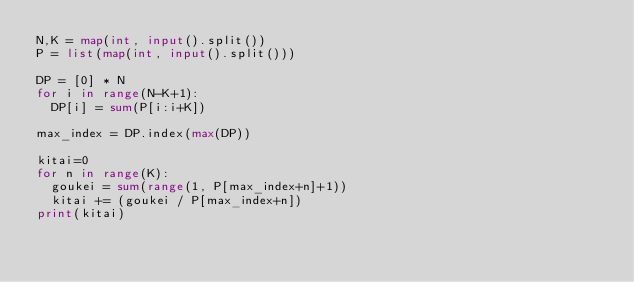<code> <loc_0><loc_0><loc_500><loc_500><_Python_>N,K = map(int, input().split())
P = list(map(int, input().split()))

DP = [0] * N
for i in range(N-K+1):
  DP[i] = sum(P[i:i+K])

max_index = DP.index(max(DP))

kitai=0
for n in range(K):
  goukei = sum(range(1, P[max_index+n]+1))
  kitai += (goukei / P[max_index+n])
print(kitai)</code> 